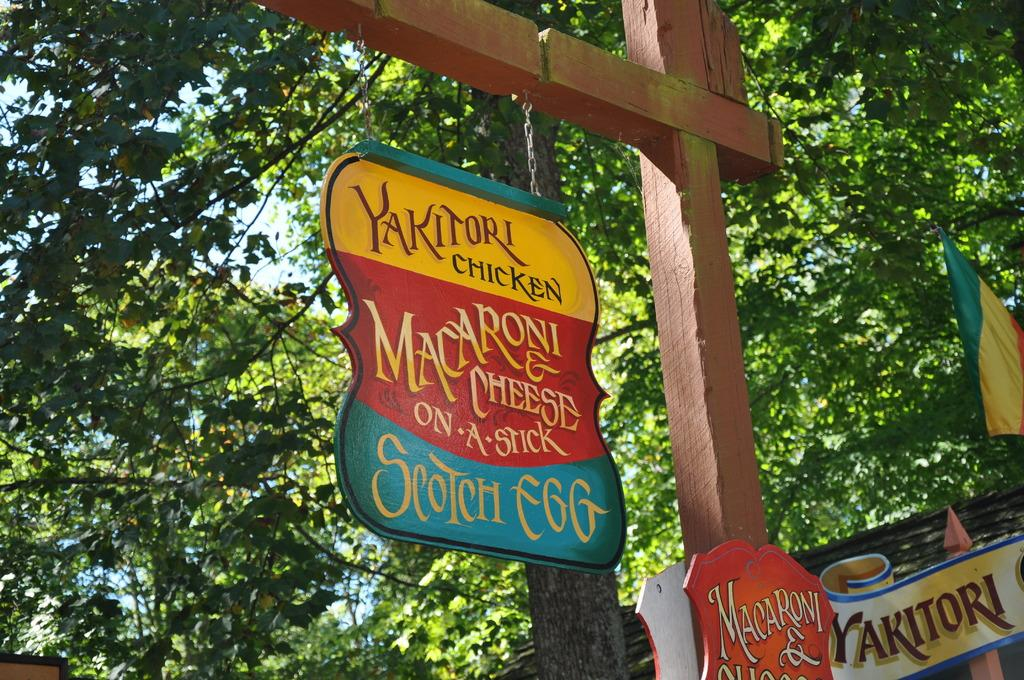What is one of the main objects in the image? There is a pole in the image. What else can be seen in the image? There is a board, a flag, and trees in the image. What is the background of the image? The sky is visible in the image. Can you tell if the image was taken during the day or night? The image was likely taken during the day, as the sky is visible. What type of whistle can be heard in the image? There is no whistle present in the image, and therefore no sound can be heard. What type of competition is taking place in the image? There is no competition depicted in the image; it only shows a pole, a board, a flag, trees, and the sky. 